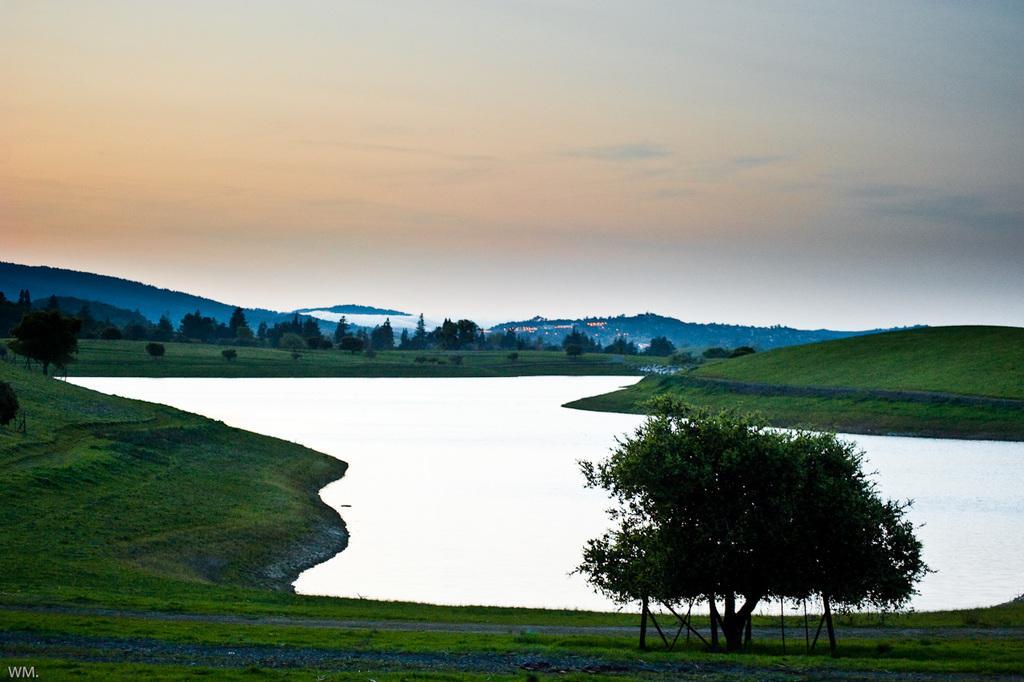Describe this image in one or two sentences. In the foreground of this image, there is a grassland a tree and the water. In the background, there are trees, grassland, mountains, few lights and the sky. 